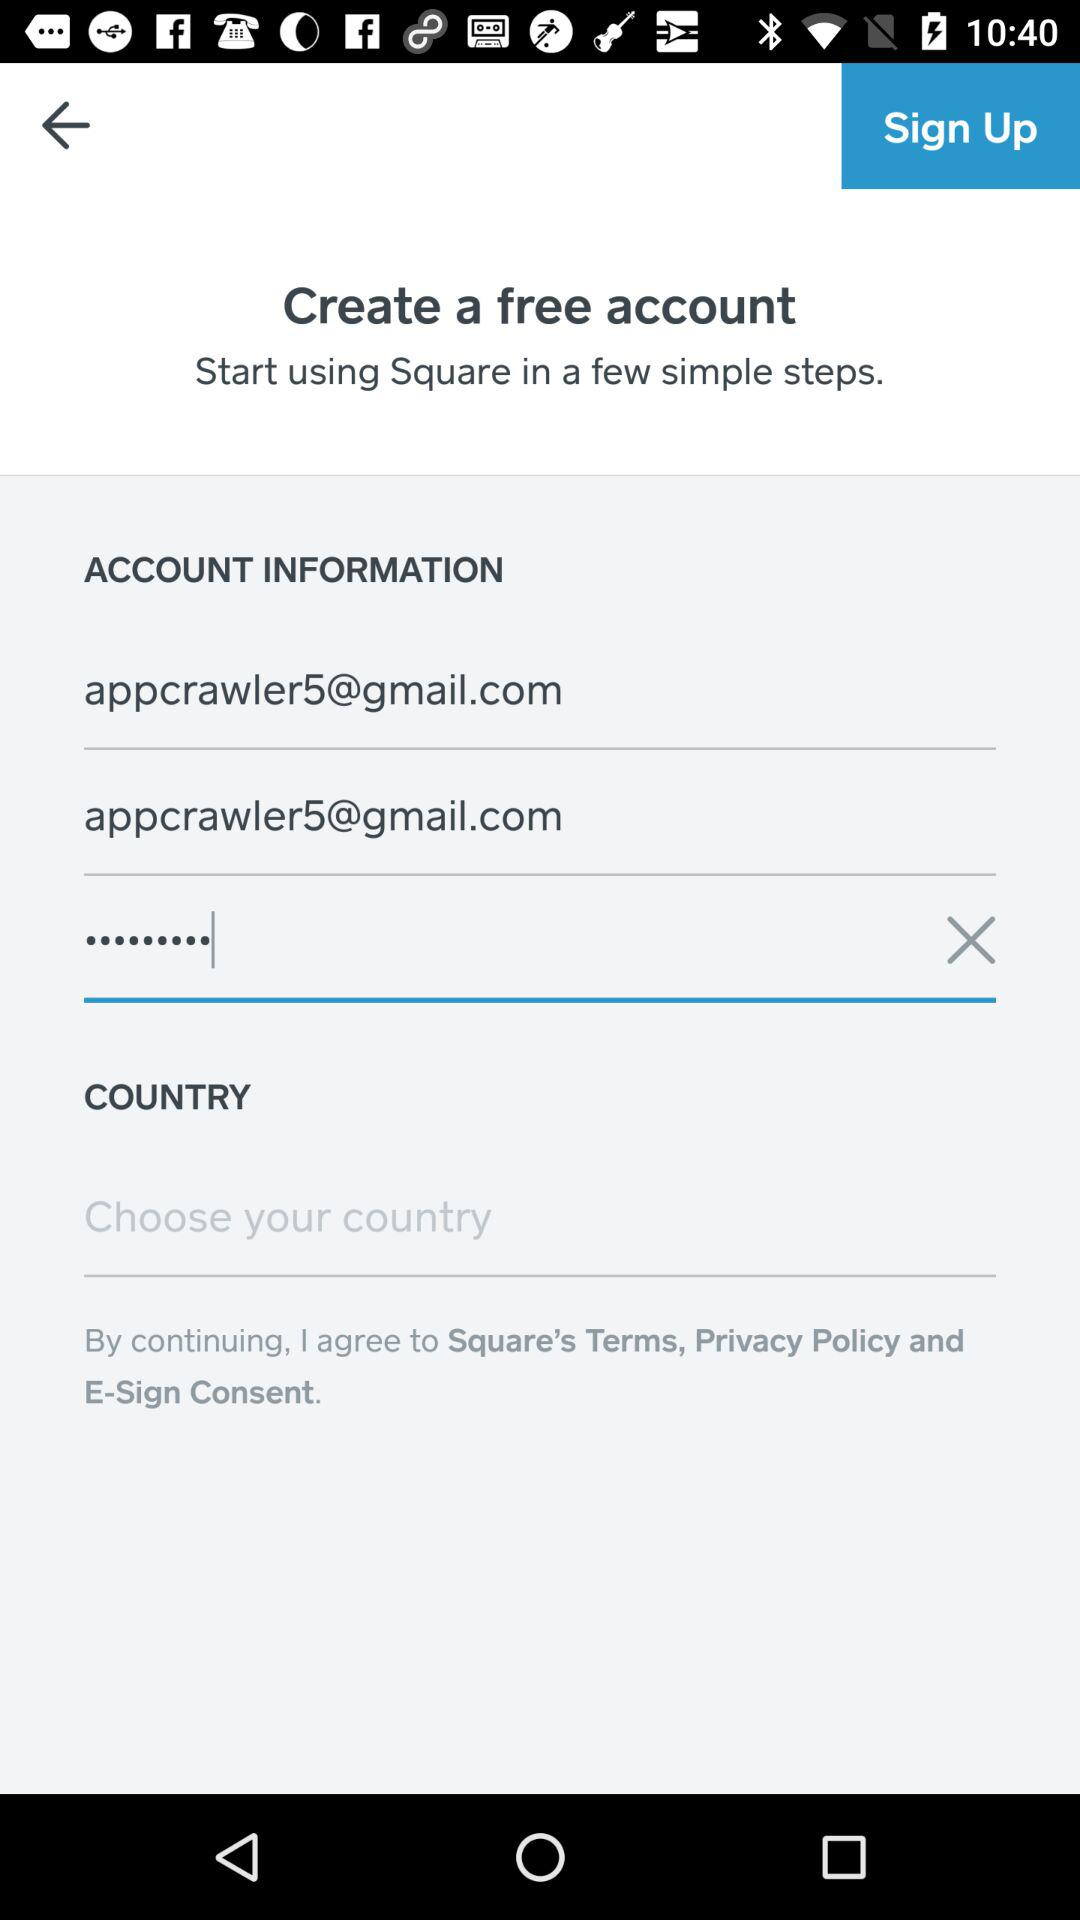What are the steps a user must follow to create an account based on this image? Based on the image, a user needs to enter a valid email address, create a password, and possibly choose their country from a dropdown menu. Lastly, they must agree to the terms and conditions before proceeding to create their account. 